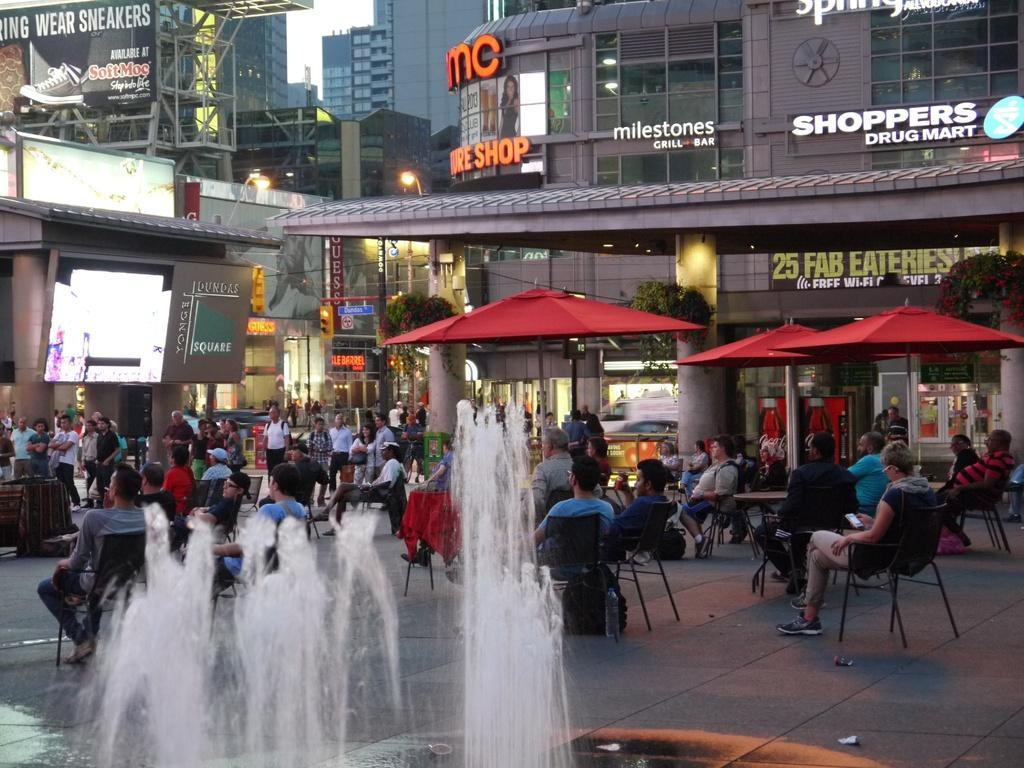Can you describe this image briefly? In this image we can see a fountain. There are many people sitting on chairs. Some people are standing. Also there are umbrellas with poles. In the back there are buildings. Also there are names on the building. And there are plants hung on the wall. Also we can see a screen. 